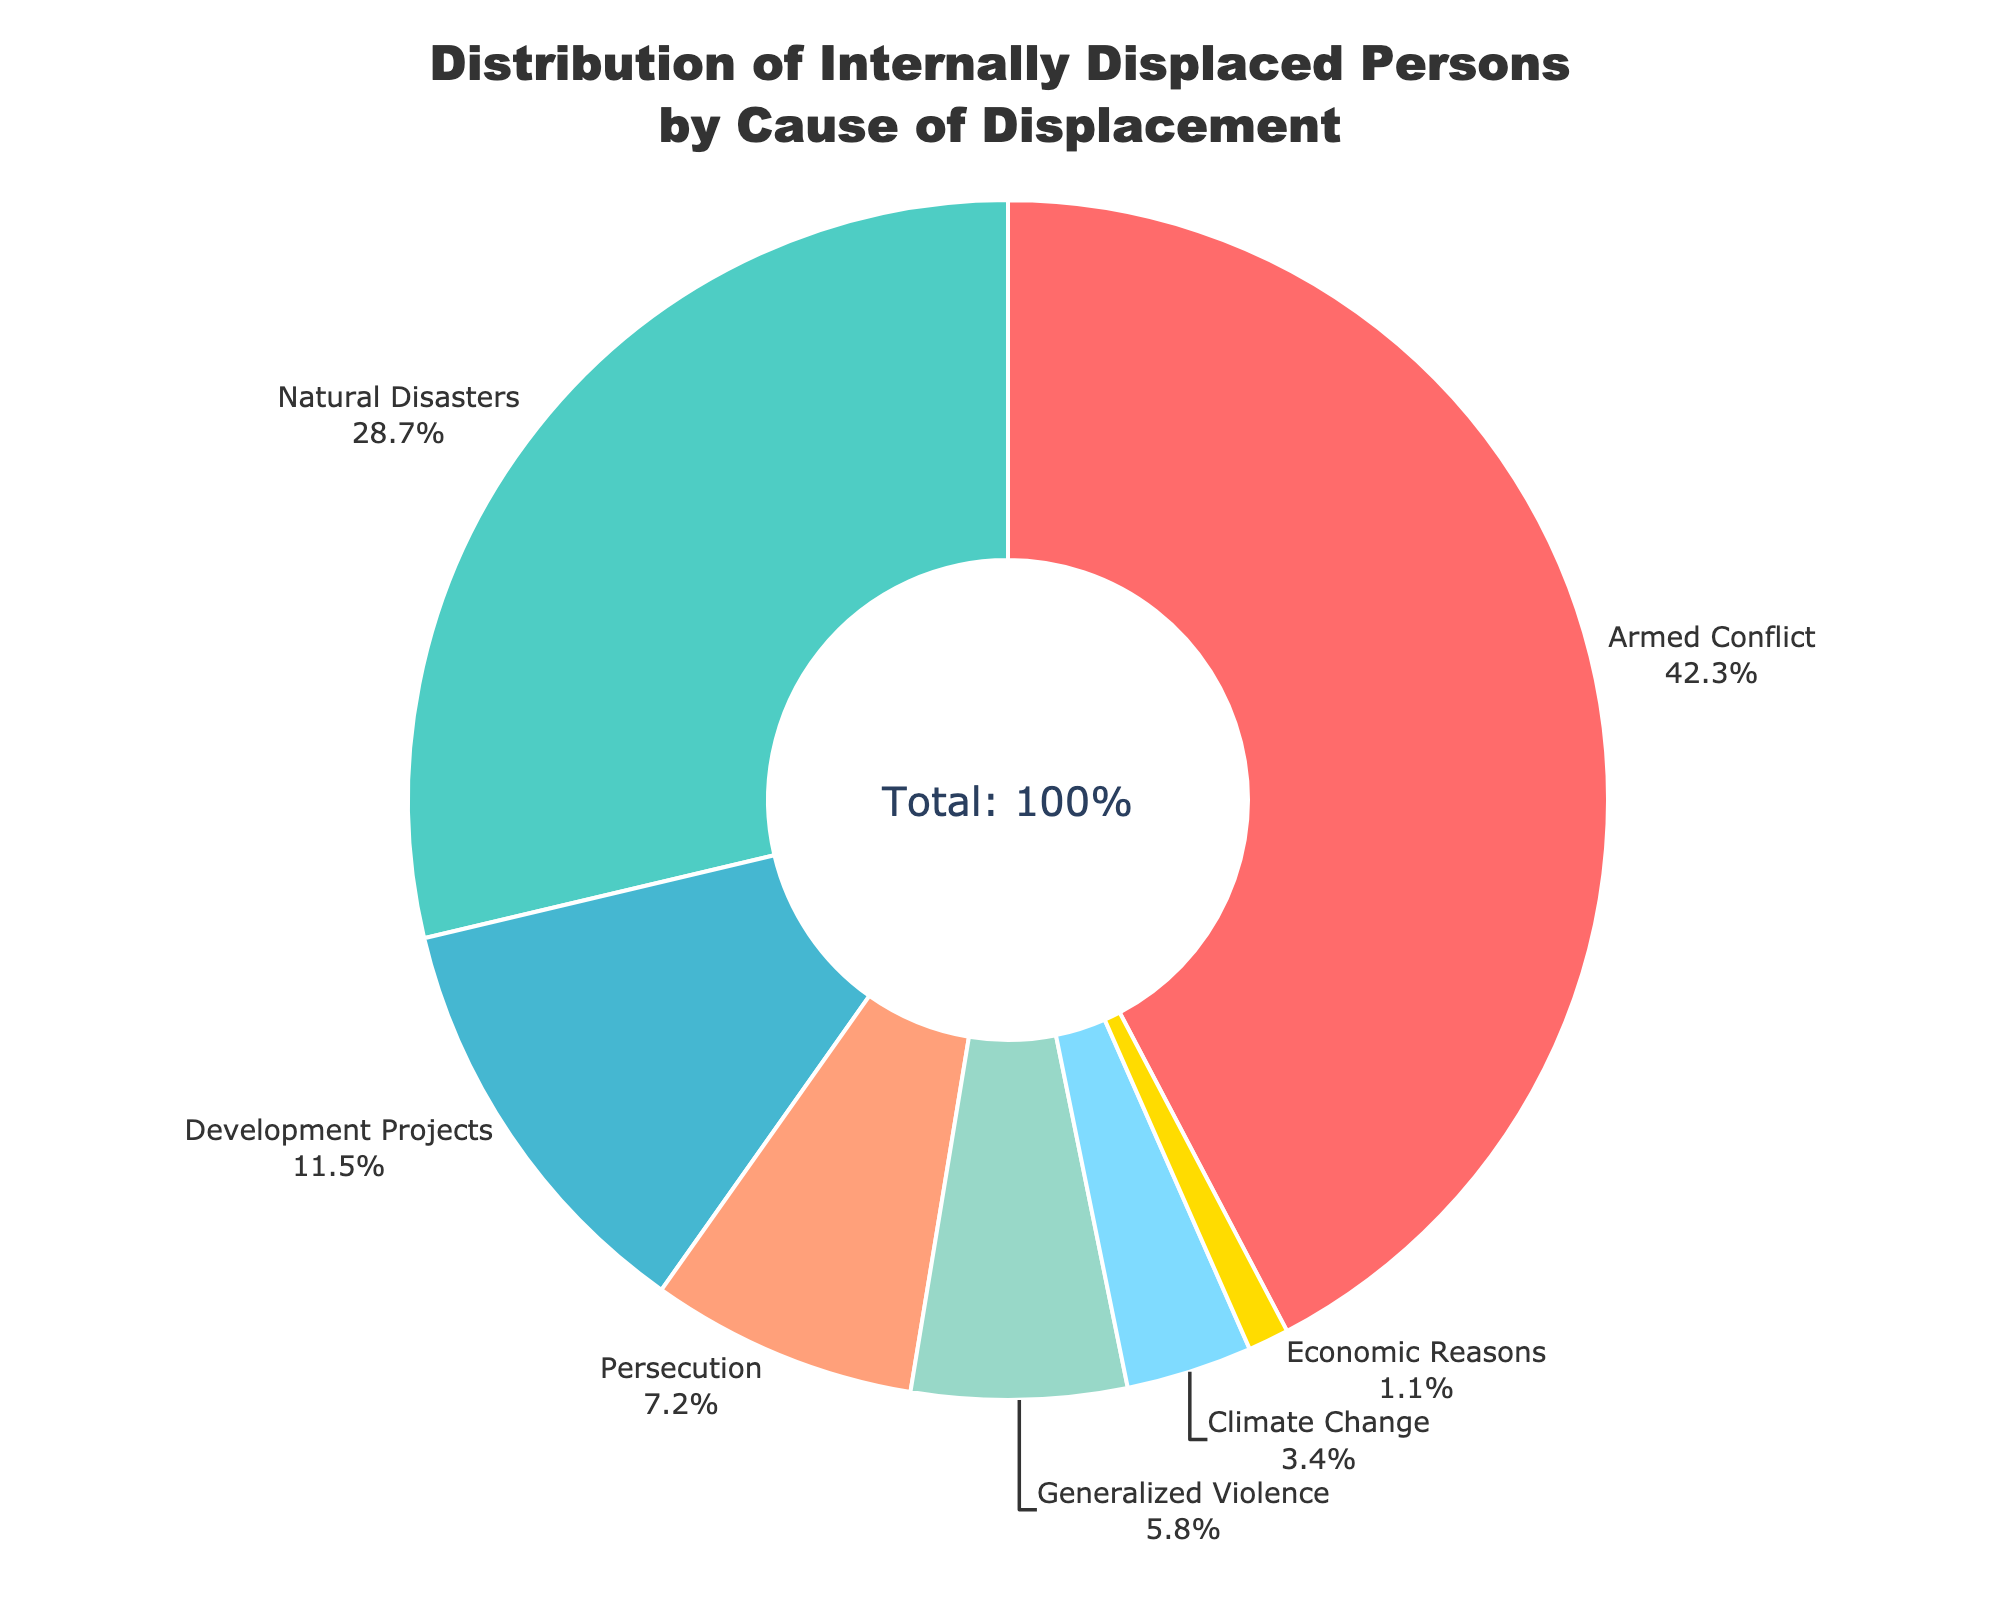Which cause of displacement has the highest percentage? The slice with the largest area and the percentage 42.3% is labeled Armed Conflict, making it the highest.
Answer: Armed Conflict Which two causes of displacement combined account for more than half of the total displacement? Summing the percentages of the two largest causes: Armed Conflict (42.3%) + Natural Disasters (28.7%) = 71%. Since 71% is more than 50%, these two causes together account for more than half.
Answer: Armed Conflict and Natural Disasters How much greater is the displacement percentage from natural disasters compared to generalized violence? The percentage for Natural Disasters is 28.7%, and for Generalized Violence it is 5.8%. Subtract 5.8% from 28.7% to find the difference.
Answer: 22.9% Which cause of displacement has the least percentage? The smallest slice, labeled 1.1%, corresponds to Economic Reasons, indicating it has the smallest percentage.
Answer: Economic Reasons By how much do persecutions and development projects together surpass climate change in percentage? First, sum Persecution (7.2%) and Development Projects (11.5%): 7.2% + 11.5% = 18.7%. Then subtract Climate Change’s percentage (3.4%) from this sum: 18.7% - 3.4% = 15.3%.
Answer: 15.3% What is the visual identifier for the cause with the second-highest displacement percentage? The slice with the second-largest area (28.7%) is labeled Natural Disasters. The visual color is turquoise-like.
Answer: Turquoise-like color Which causes of displacement have a combined percentage close to one-third of the total displacement? Summing the percentages of Generalized Violence (5.8%), Climate Change (3.4%), and Economic Reasons (1.1%): 5.8% + 3.4% + 1.1% = 10.3%. Then adding Persecution (7.2%): 10.3% + 7.2% = 17.5%, and lastly adding Development Projects (11.5%): 17.5% + 11.5% = 29%, which is close to one-third (approximately 33%).
Answer: Generalized Violence, Climate Change, Economic Reasons, Persecution, and Development Projects What percentage of internally displaced persons is due to non-natural causes? Sum the percentages of all causes excluding Natural Disasters: Armed Conflict (42.3%), Development Projects (11.5%), Persecution (7.2%), Generalized Violence (5.8%), Climate Change (3.4%), and Economic Reasons (1.1%). 42.3% + 11.5% + 7.2% + 5.8% + 3.4% + 1.1% = 71.3%.
Answer: 71.3% What percentage difference exists between displacement caused by development projects and by economic reasons? The percentage for Development Projects is 11.5% and for Economic Reasons is 1.1%. Subtract 1.1% from 11.5% to find the difference.
Answer: 10.4% What causes of displacement account for less than 10% each? Reviewing each segment's percentage, we find that Persecution (7.2%), Generalized Violence (5.8%), Climate Change (3.4%), and Economic Reasons (1.1%) all fall below 10%.
Answer: Persecution, Generalized Violence, Climate Change, Economic Reasons 